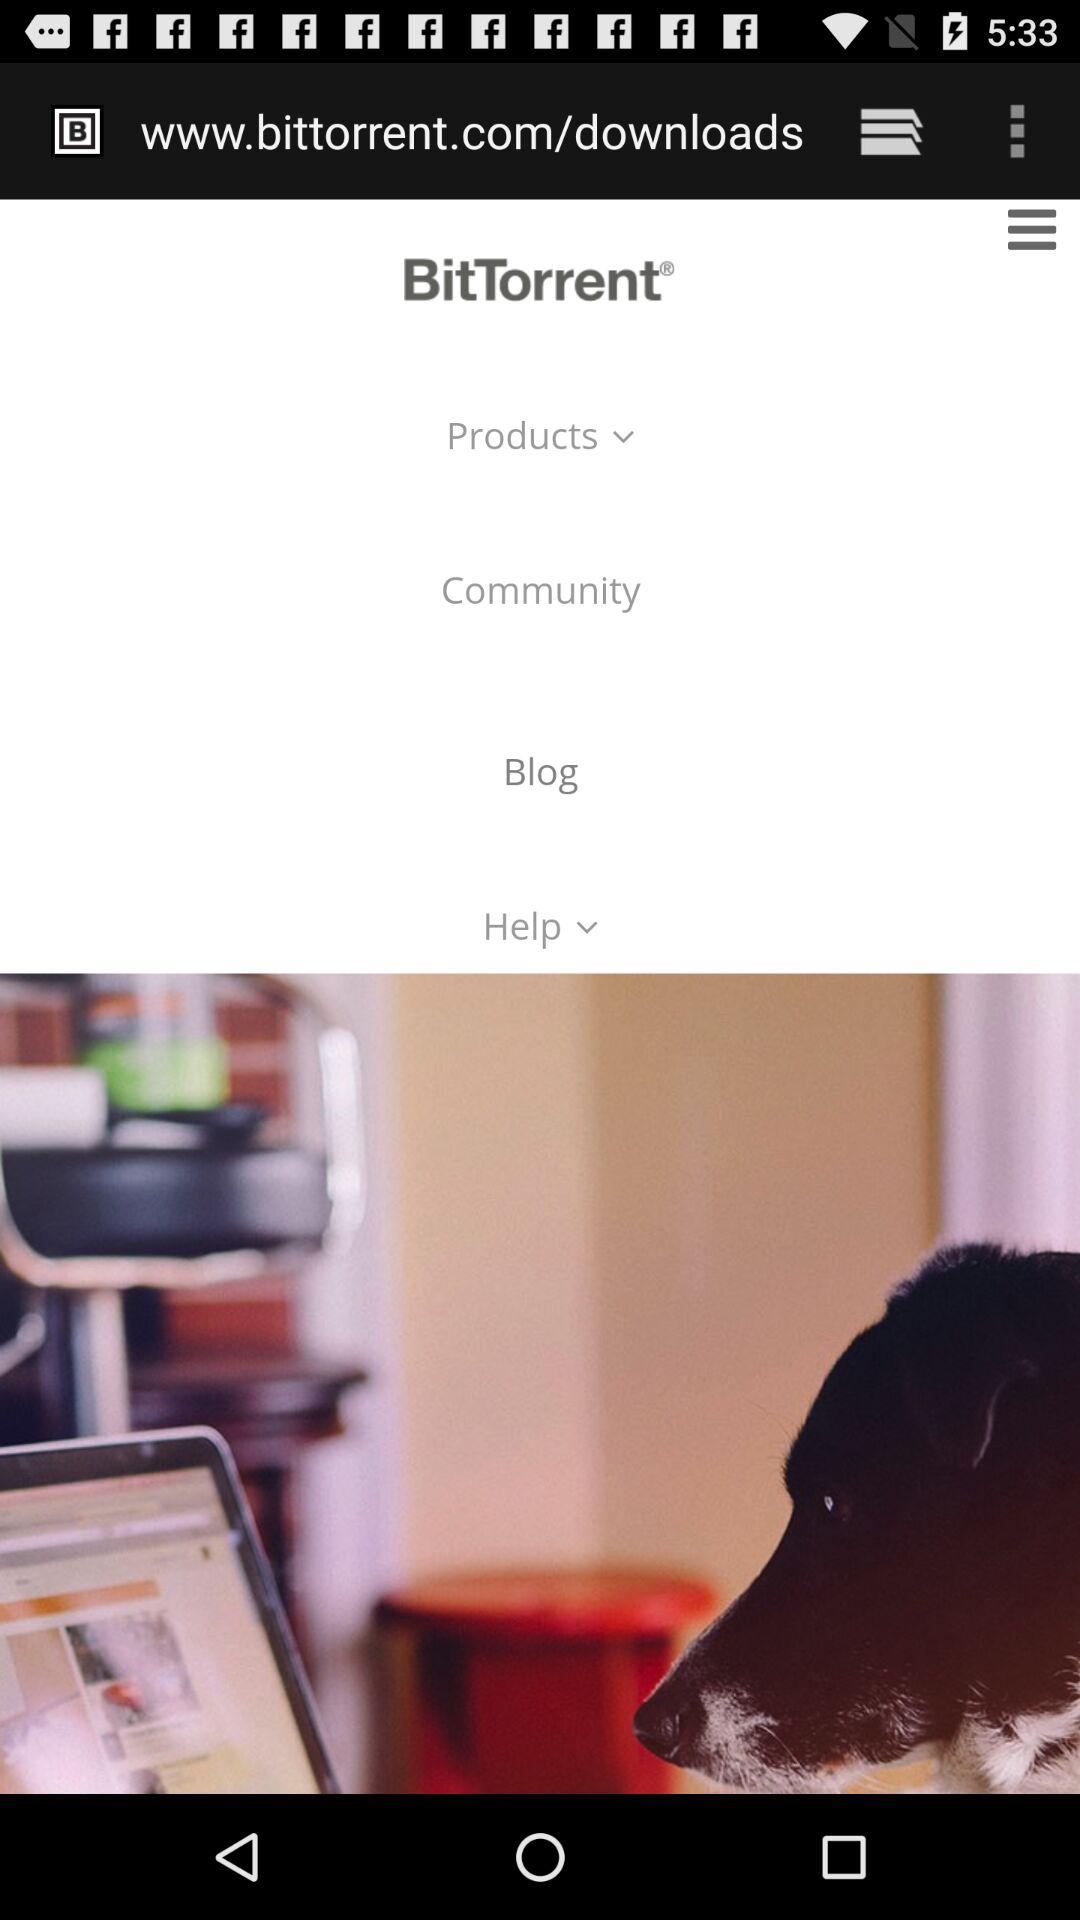What is the name of the application? The name of the application is "BitTorrent". 